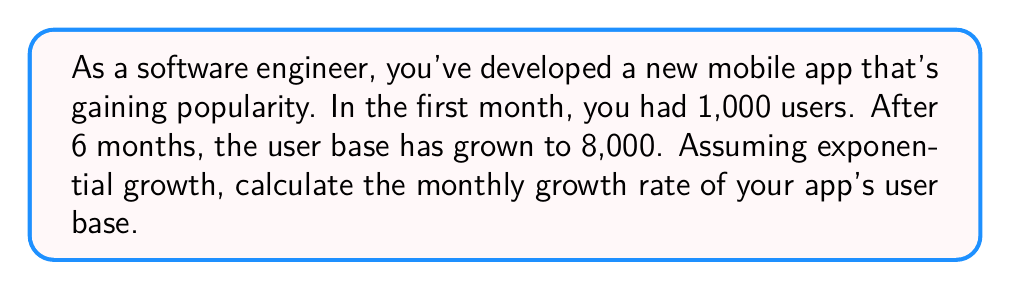Teach me how to tackle this problem. Let's approach this step-by-step using the exponential growth formula:

1) The exponential growth formula is:
   $$A = P(1 + r)^t$$
   Where:
   $A$ = Final amount
   $P$ = Initial amount
   $r$ = Growth rate (as a decimal)
   $t$ = Time periods

2) We know:
   $P = 1,000$ (initial users)
   $A = 8,000$ (final users)
   $t = 6$ (months)

3) Let's plug these into our formula:
   $$8,000 = 1,000(1 + r)^6$$

4) Divide both sides by 1,000:
   $$8 = (1 + r)^6$$

5) Take the 6th root of both sides:
   $$\sqrt[6]{8} = 1 + r$$

6) Simplify:
   $$8^{\frac{1}{6}} = 1 + r$$

7) Subtract 1 from both sides:
   $$8^{\frac{1}{6}} - 1 = r$$

8) Calculate:
   $$r \approx 1.4142 - 1 = 0.4142$$

9) Convert to a percentage:
   $$0.4142 \times 100\% = 41.42\%$$

Therefore, the monthly growth rate is approximately 41.42%.
Answer: 41.42% 